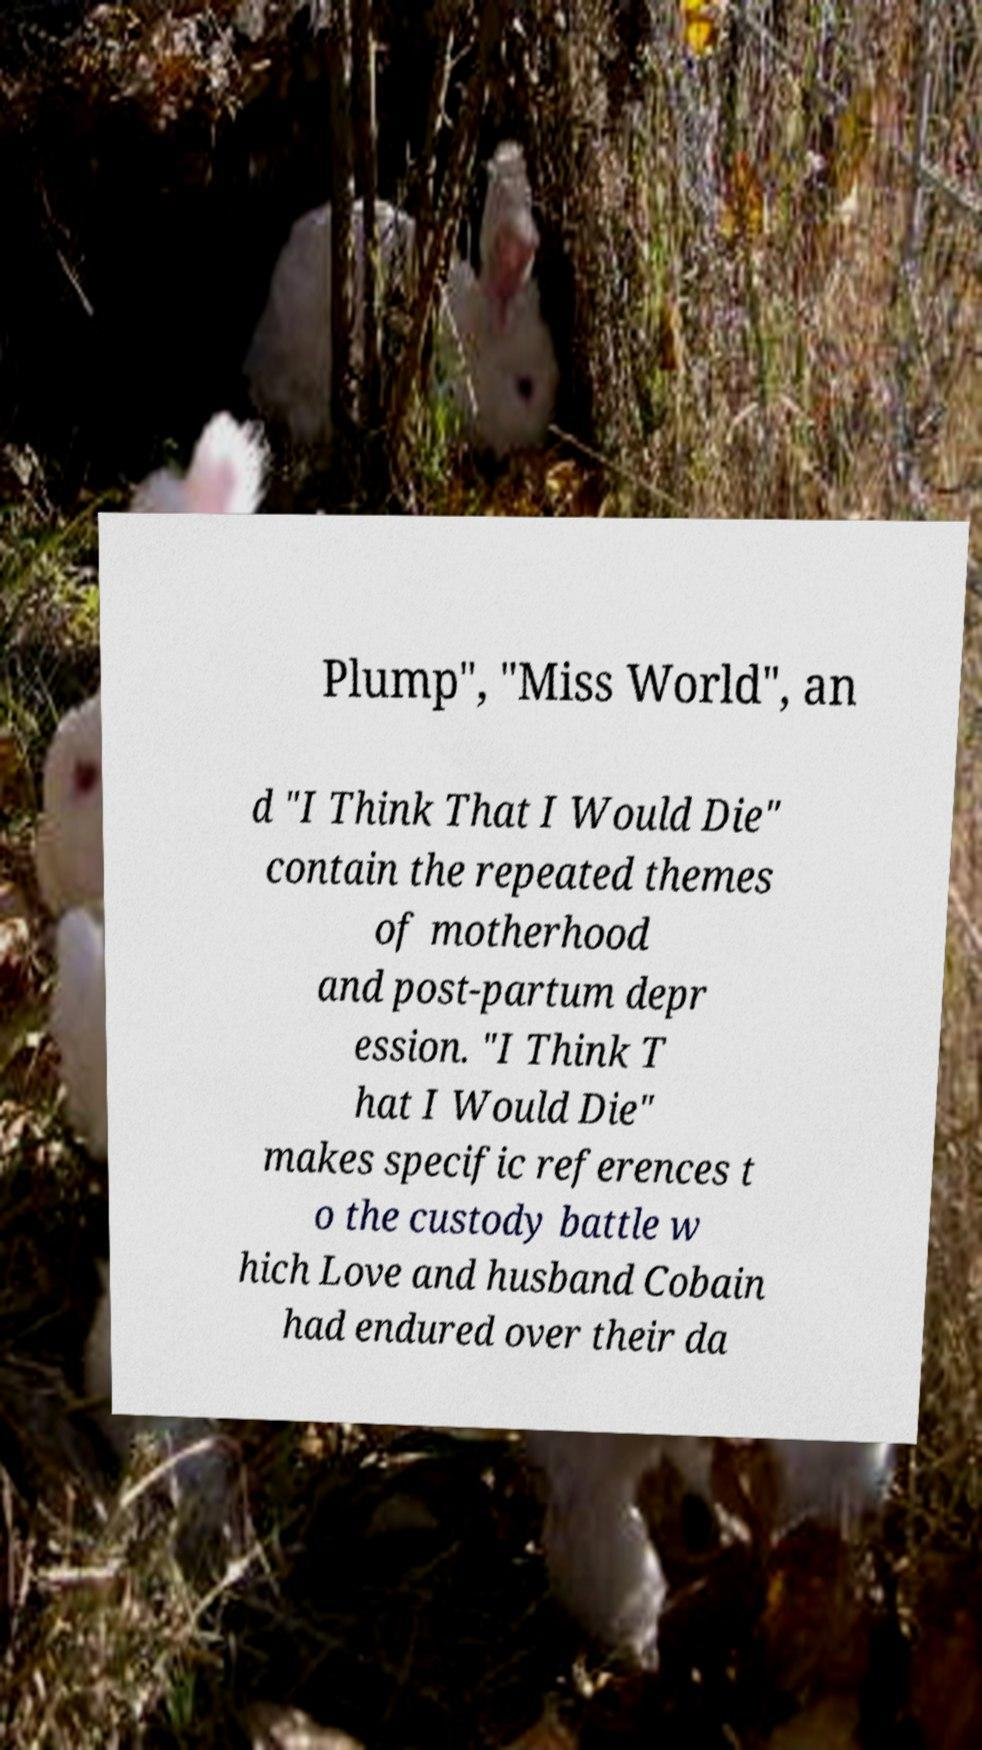Please read and relay the text visible in this image. What does it say? Plump", "Miss World", an d "I Think That I Would Die" contain the repeated themes of motherhood and post-partum depr ession. "I Think T hat I Would Die" makes specific references t o the custody battle w hich Love and husband Cobain had endured over their da 